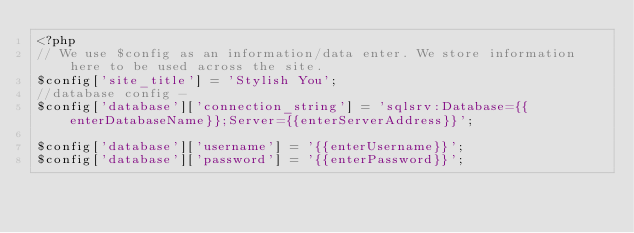Convert code to text. <code><loc_0><loc_0><loc_500><loc_500><_PHP_><?php
// We use $config as an information/data enter. We store information here to be used across the site.
$config['site_title'] = 'Stylish You';
//database config - 
$config['database']['connection_string'] = 'sqlsrv:Database={{enterDatabaseName}};Server={{enterServerAddress}}';

$config['database']['username'] = '{{enterUsername}}'; 
$config['database']['password'] = '{{enterPassword}}';</code> 